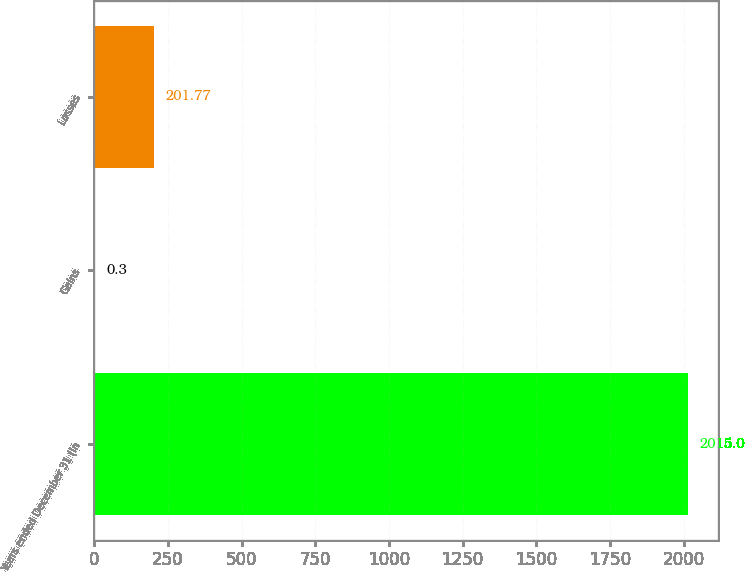Convert chart to OTSL. <chart><loc_0><loc_0><loc_500><loc_500><bar_chart><fcel>Years ended December 31 (in<fcel>Gains<fcel>Losses<nl><fcel>2015<fcel>0.3<fcel>201.77<nl></chart> 